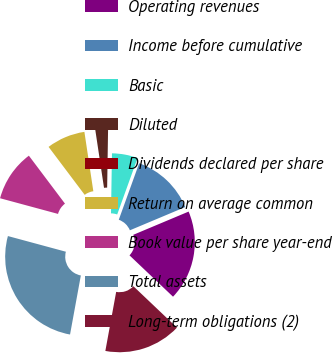<chart> <loc_0><loc_0><loc_500><loc_500><pie_chart><fcel>Operating revenues<fcel>Income before cumulative<fcel>Basic<fcel>Diluted<fcel>Dividends declared per share<fcel>Return on average common<fcel>Book value per share year-end<fcel>Total assets<fcel>Long-term obligations (2)<nl><fcel>18.42%<fcel>13.16%<fcel>5.26%<fcel>2.63%<fcel>0.0%<fcel>7.89%<fcel>10.53%<fcel>26.32%<fcel>15.79%<nl></chart> 